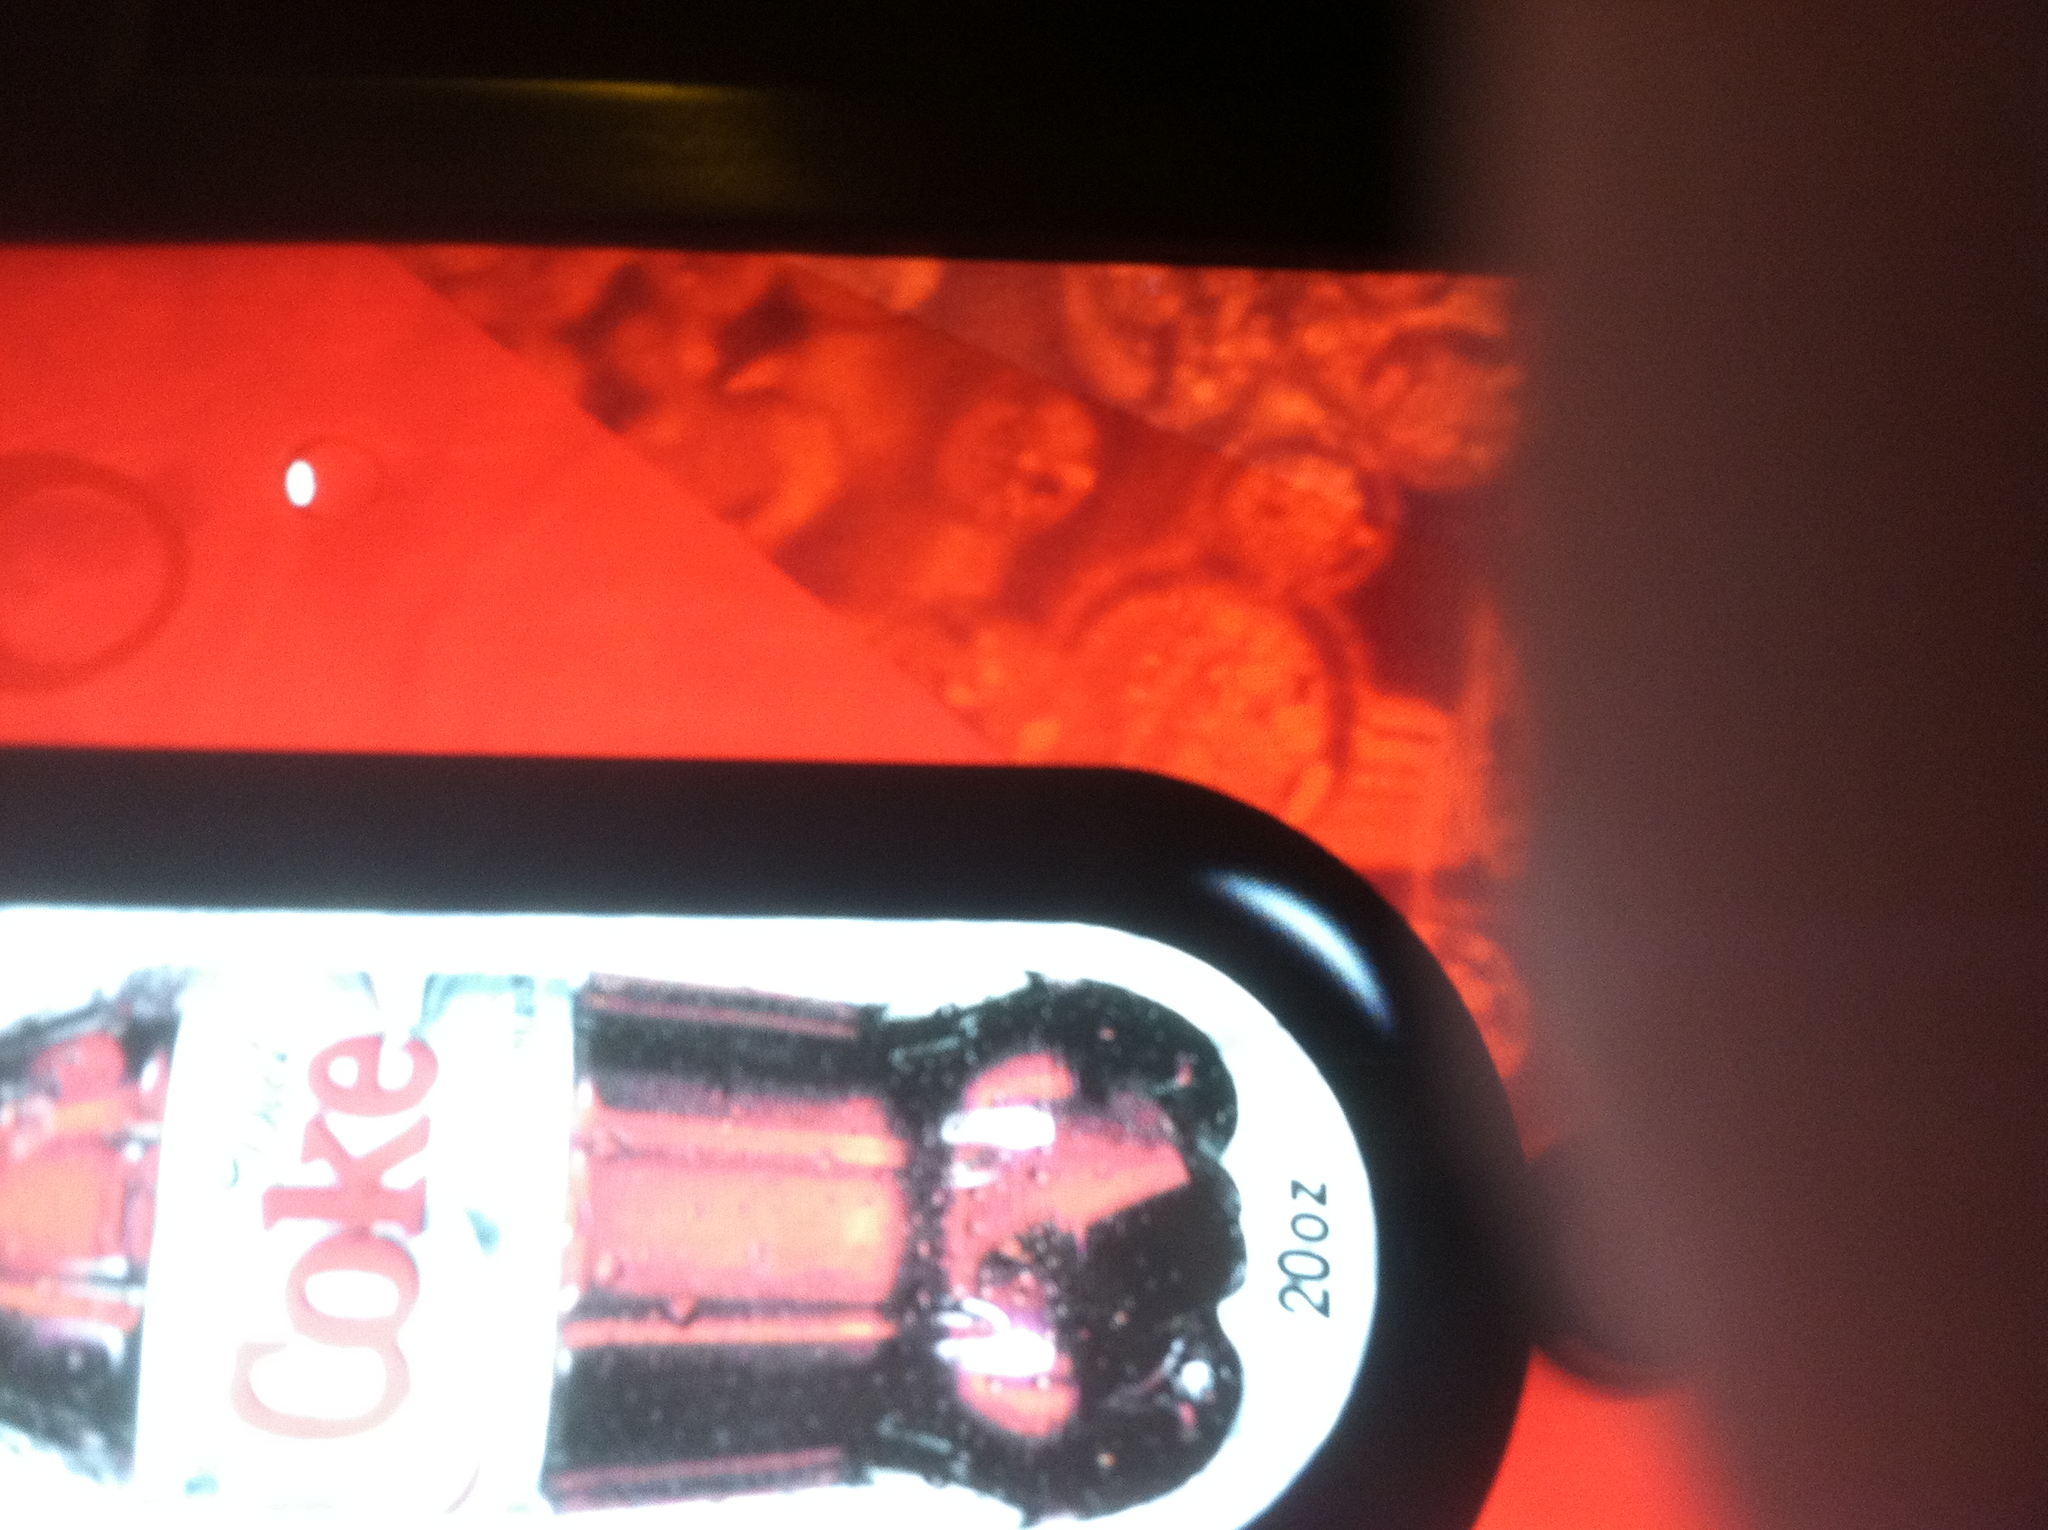If this image were to inspire a scene in a movie, what genre would it most likely fit into, and why? This image could inspire a scene in a science fiction movie, with its striking red and modern design elements creating a futuristic or technologically advanced atmosphere. It could also fit into a thriller, where the low lighting and intense colors add to a sense of mystery and suspense. Imagine this vending machine is a portal to another world. What kind of world would it lead to? If this vending machine were a portal to another world, it might lead to a vibrant, neon-lit city where everything is infused with digital technology. The red and silver color scheme could reflect the sleek, high-energy vibe of this world, where soft drinks are not just beverages but also contain micro-bots that give you additional energy and mental clarity. 